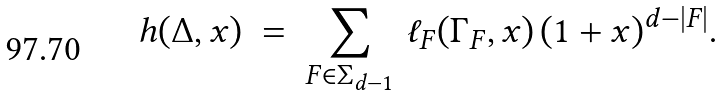<formula> <loc_0><loc_0><loc_500><loc_500>h ( \Delta , x ) \ = \ \sum _ { F \in \Sigma _ { d - 1 } } \, \ell _ { F } ( \Gamma _ { F } , x ) \, ( 1 + x ) ^ { d - | F | } .</formula> 